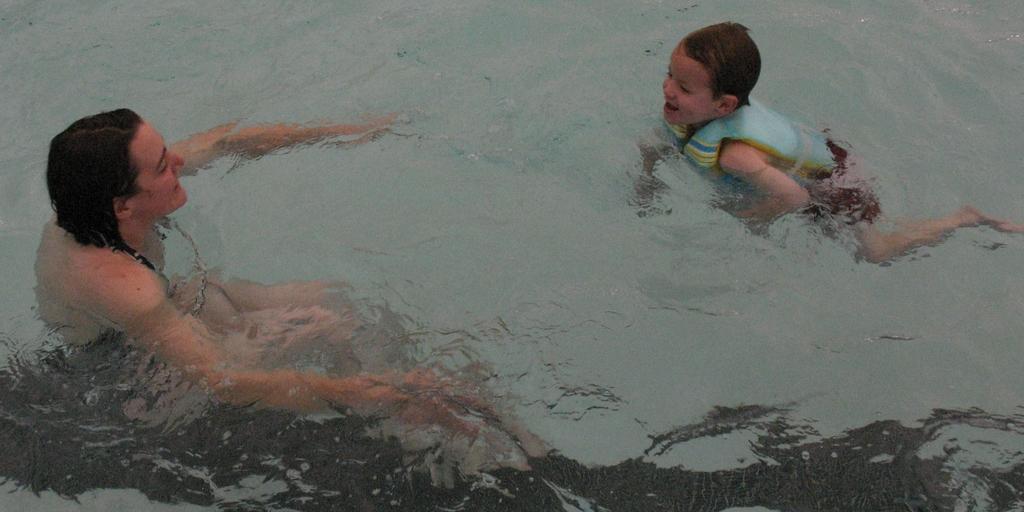Describe this image in one or two sentences. This image consists of a woman and a kid swimming. At the bottom, there is a water. 